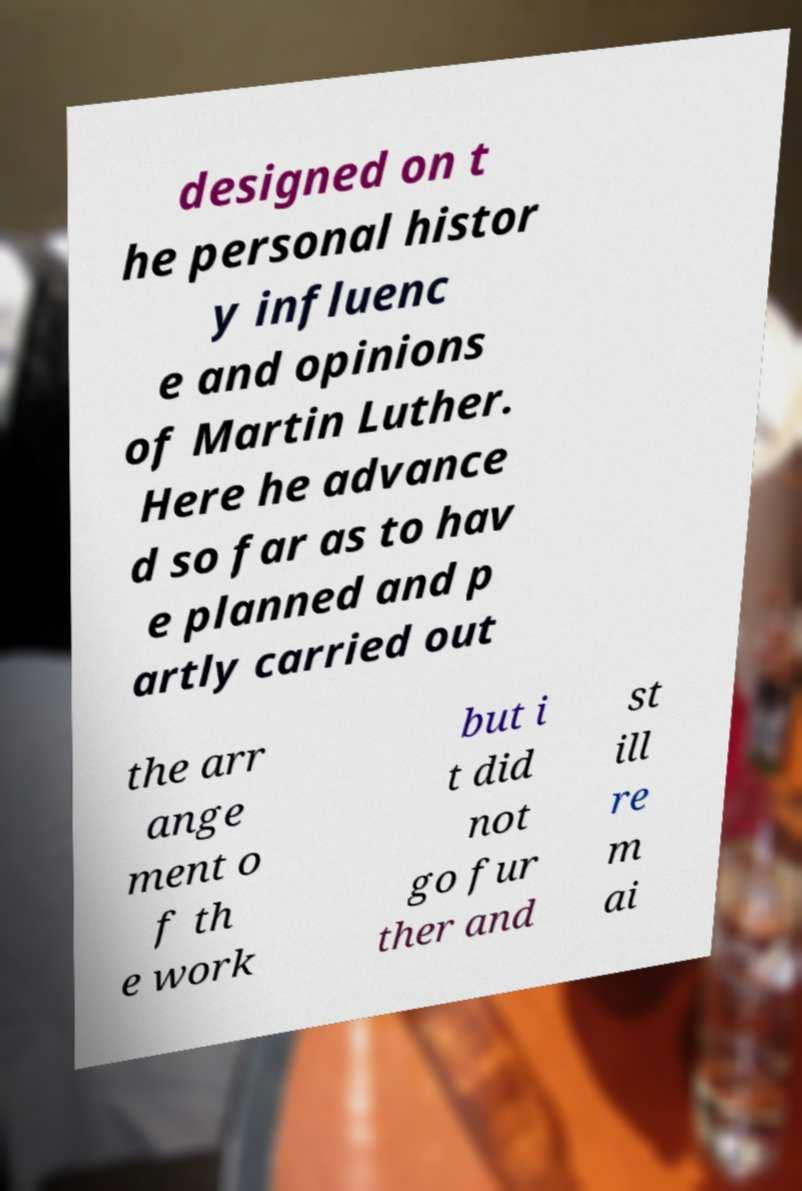Please identify and transcribe the text found in this image. designed on t he personal histor y influenc e and opinions of Martin Luther. Here he advance d so far as to hav e planned and p artly carried out the arr ange ment o f th e work but i t did not go fur ther and st ill re m ai 